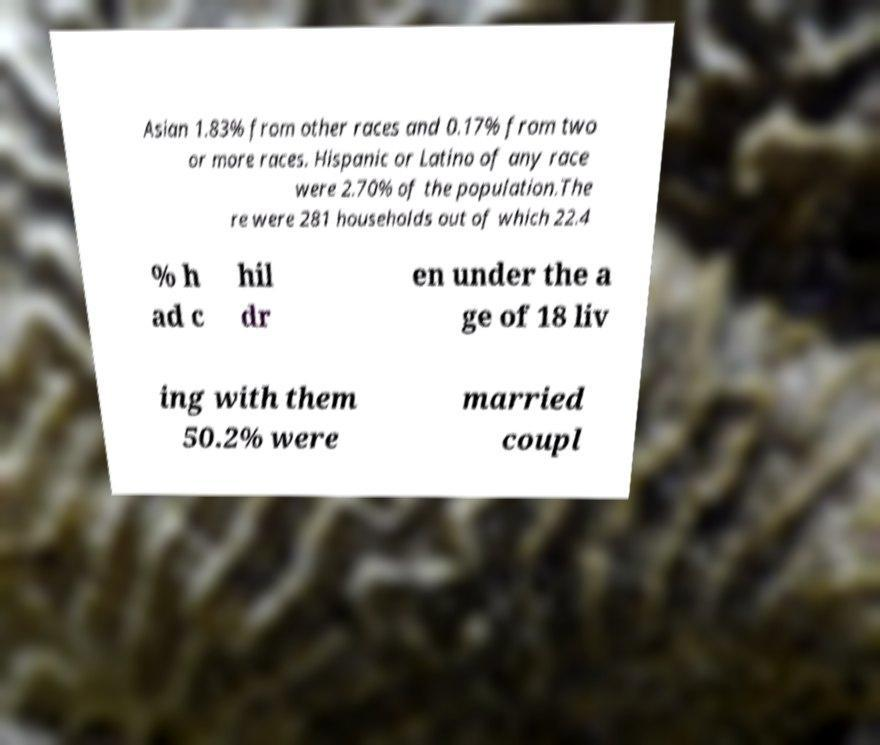Could you assist in decoding the text presented in this image and type it out clearly? Asian 1.83% from other races and 0.17% from two or more races. Hispanic or Latino of any race were 2.70% of the population.The re were 281 households out of which 22.4 % h ad c hil dr en under the a ge of 18 liv ing with them 50.2% were married coupl 